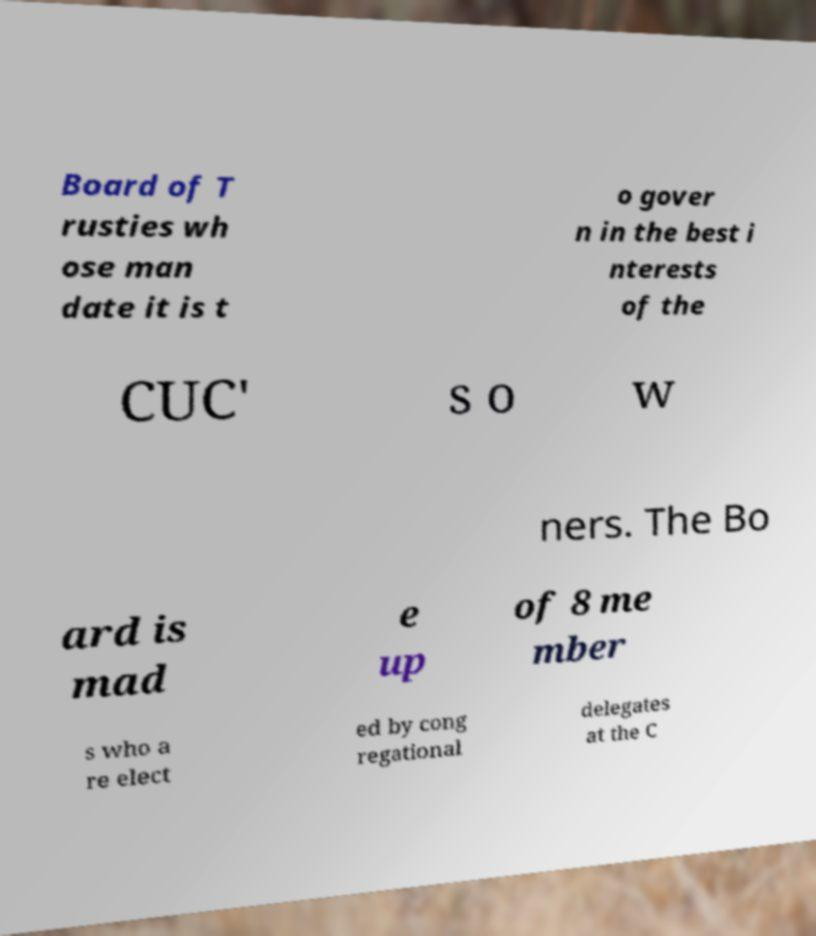For documentation purposes, I need the text within this image transcribed. Could you provide that? Board of T rusties wh ose man date it is t o gover n in the best i nterests of the CUC' s o w ners. The Bo ard is mad e up of 8 me mber s who a re elect ed by cong regational delegates at the C 